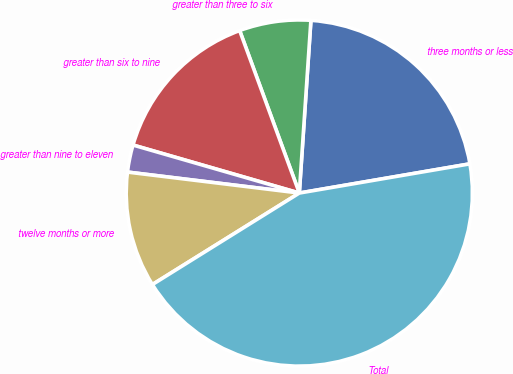Convert chart. <chart><loc_0><loc_0><loc_500><loc_500><pie_chart><fcel>three months or less<fcel>greater than three to six<fcel>greater than six to nine<fcel>greater than nine to eleven<fcel>twelve months or more<fcel>Total<nl><fcel>21.24%<fcel>6.67%<fcel>14.93%<fcel>2.54%<fcel>10.8%<fcel>43.84%<nl></chart> 